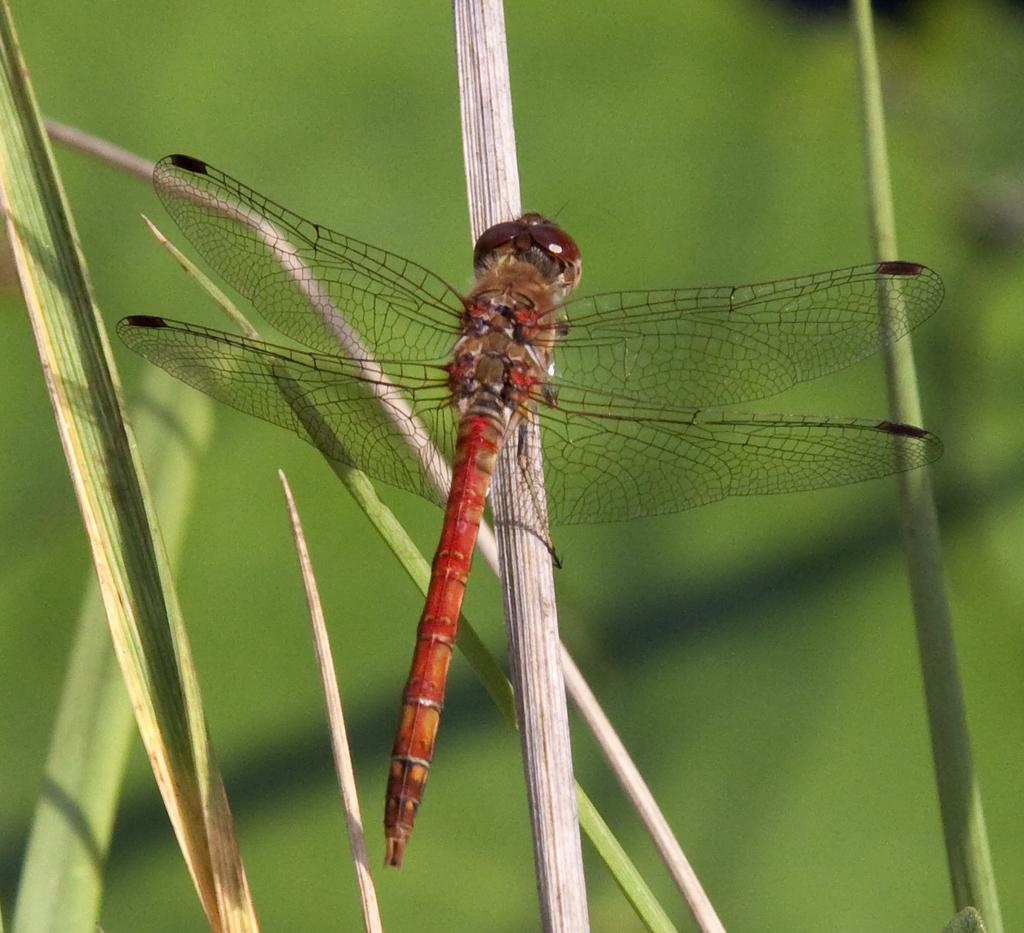What insect is present on a dried leaf in the image? There is a dragonfly on a dried leaf in the image. What else can be seen in the image besides the dragonfly? There are leaves in the image. How would you describe the background of the image? The background is blurred and green. What type of pets are visible in the image? There are no pets present in the image. Can you see a quill being used to write in the image? There is no quill or writing activity depicted in the image. 